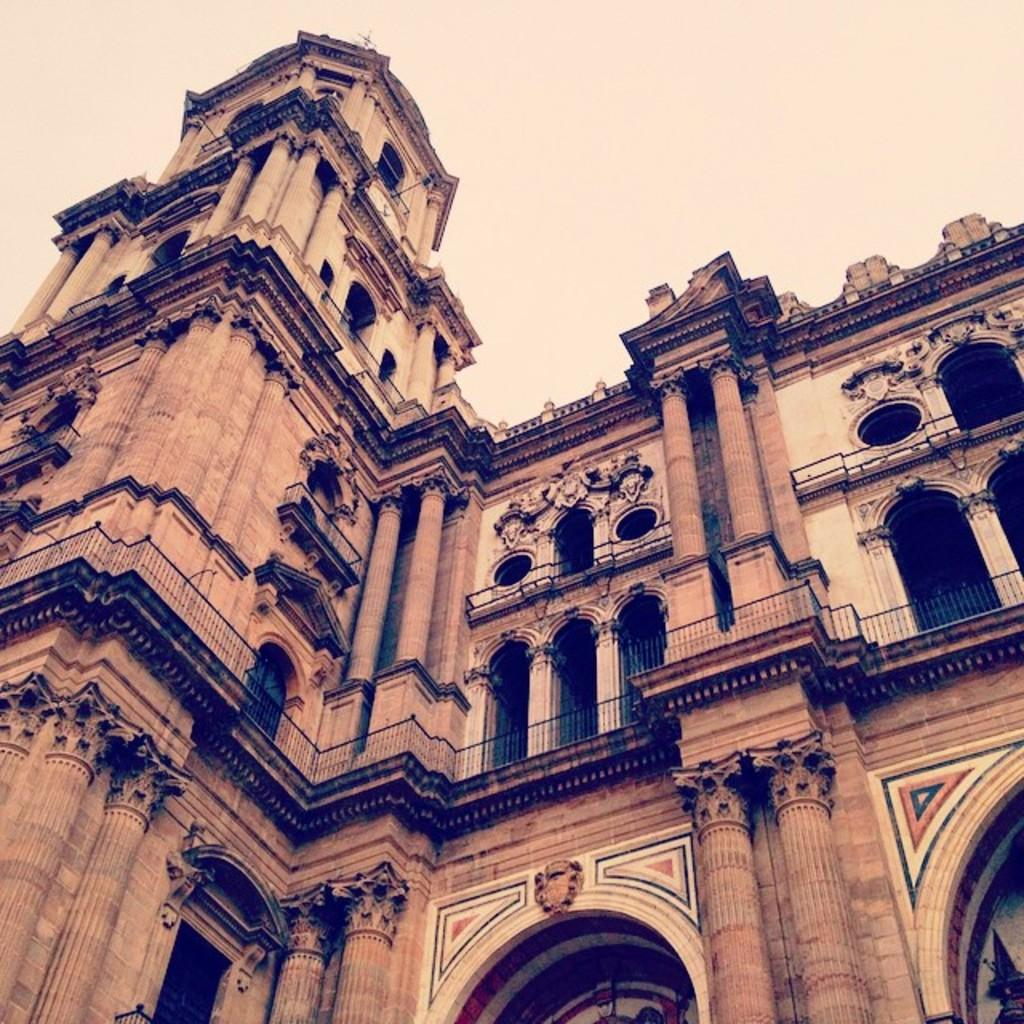What type of structure is present in the image? There is a building in the image. What features can be observed on the building? The building has windows, a railing, and pillars. Are there any decorative elements on the building? Yes, there are sculptures on the walls of the building. What is visible at the top of the image? The sky is visible at the top of the image. Can you tell me how many hooks are attached to the sculptures on the building? There is no mention of hooks in the image, as it features a building with windows, a railing, pillars, and sculptures on the walls. 